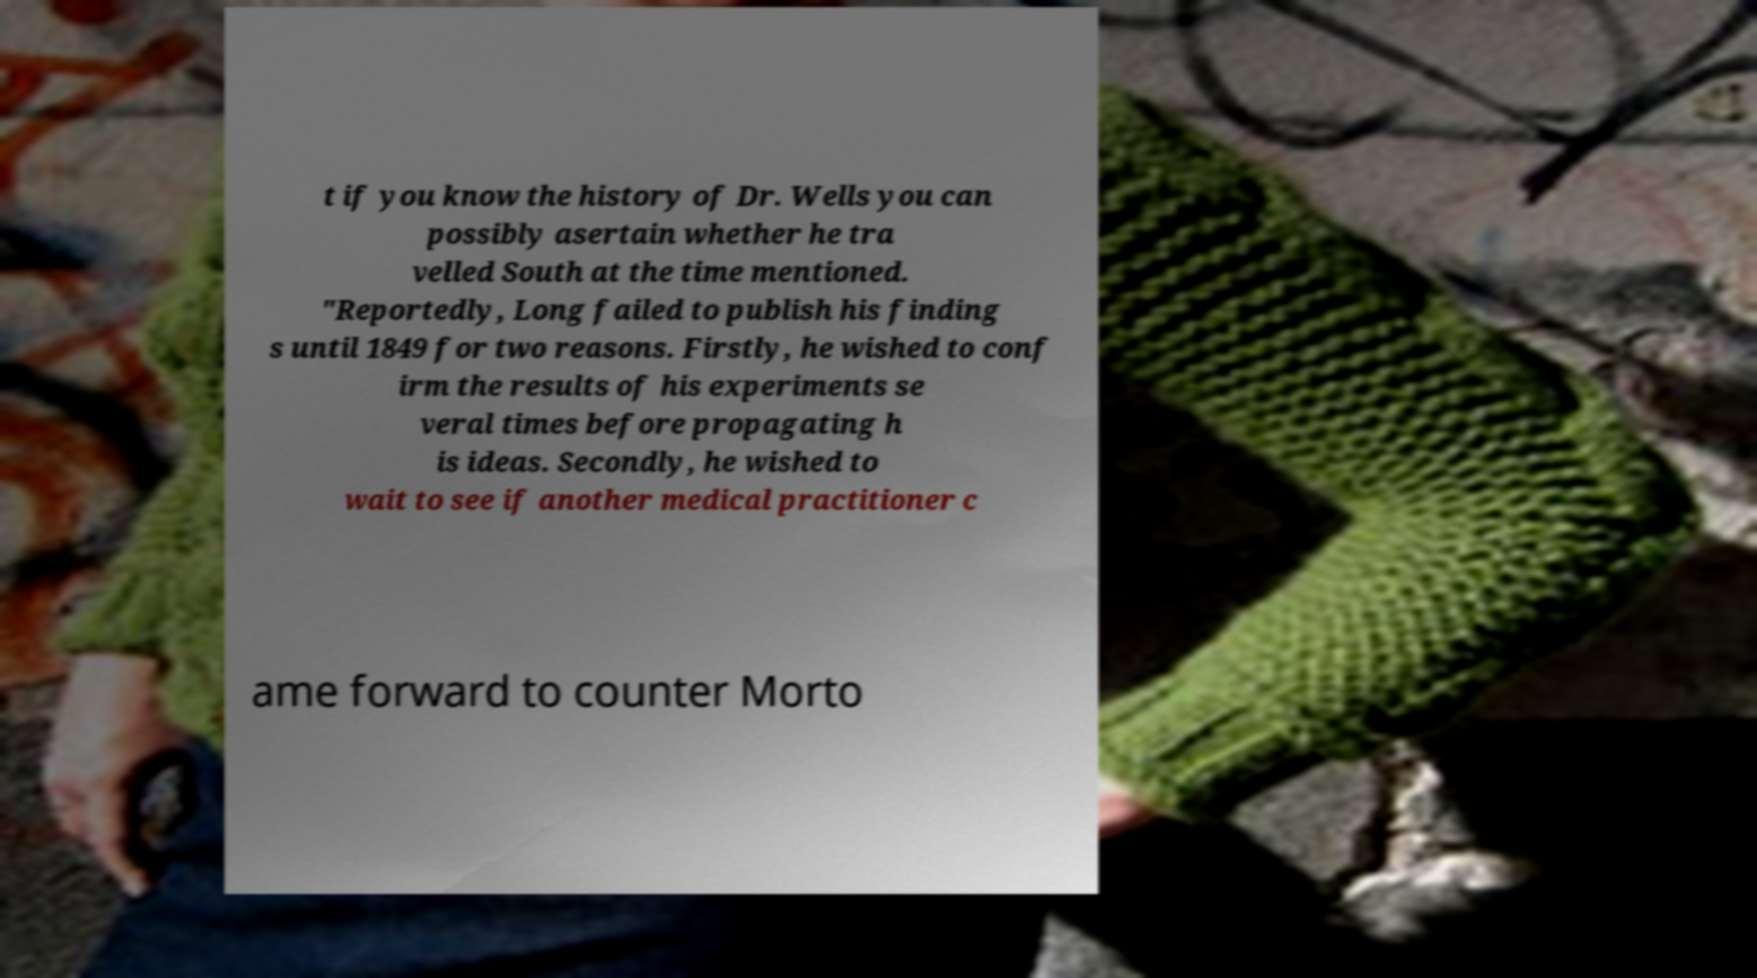What messages or text are displayed in this image? I need them in a readable, typed format. t if you know the history of Dr. Wells you can possibly asertain whether he tra velled South at the time mentioned. "Reportedly, Long failed to publish his finding s until 1849 for two reasons. Firstly, he wished to conf irm the results of his experiments se veral times before propagating h is ideas. Secondly, he wished to wait to see if another medical practitioner c ame forward to counter Morto 